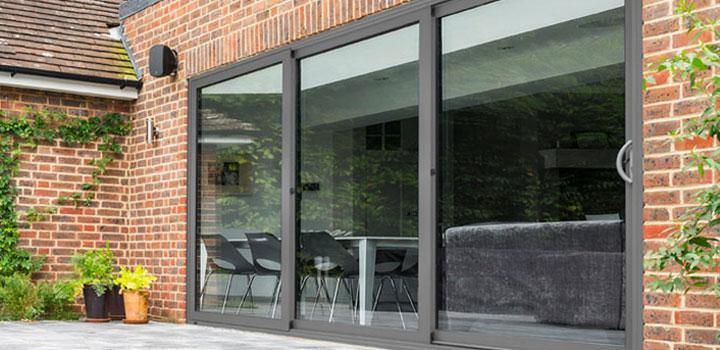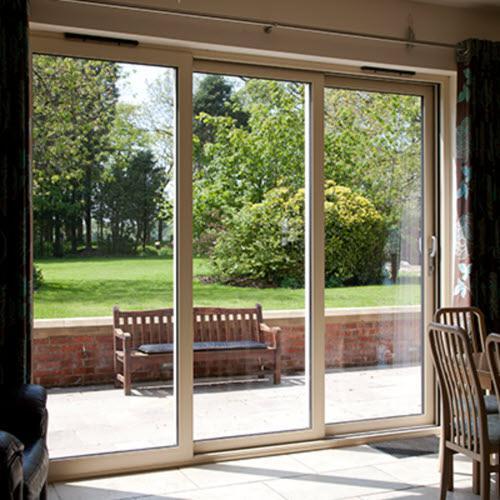The first image is the image on the left, the second image is the image on the right. For the images displayed, is the sentence "A woman is standing by the opening in the image on the left." factually correct? Answer yes or no. No. The first image is the image on the left, the second image is the image on the right. Given the left and right images, does the statement "An image shows one woman standing and touching a sliding door element." hold true? Answer yes or no. No. 